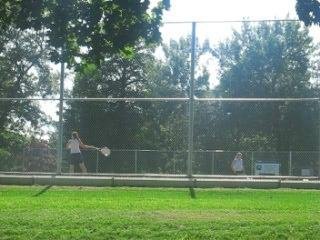What would this fence help to contain?

Choices:
A) balls
B) animals
C) rocks
D) weeds balls 